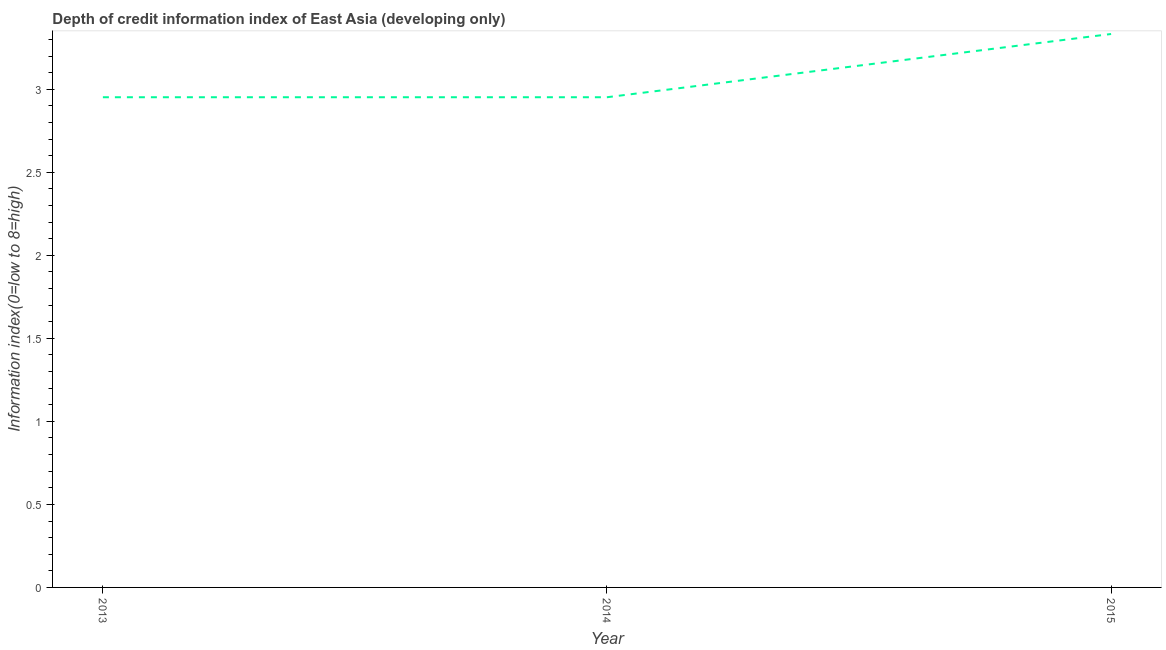What is the depth of credit information index in 2015?
Your answer should be very brief. 3.33. Across all years, what is the maximum depth of credit information index?
Keep it short and to the point. 3.33. Across all years, what is the minimum depth of credit information index?
Provide a short and direct response. 2.95. In which year was the depth of credit information index maximum?
Your answer should be very brief. 2015. In which year was the depth of credit information index minimum?
Provide a succinct answer. 2013. What is the sum of the depth of credit information index?
Offer a terse response. 9.24. What is the difference between the depth of credit information index in 2013 and 2015?
Your answer should be very brief. -0.38. What is the average depth of credit information index per year?
Your answer should be very brief. 3.08. What is the median depth of credit information index?
Your answer should be compact. 2.95. Do a majority of the years between 2015 and 2014 (inclusive) have depth of credit information index greater than 3.2 ?
Provide a succinct answer. No. Is the depth of credit information index in 2013 less than that in 2015?
Your response must be concise. Yes. Is the difference between the depth of credit information index in 2014 and 2015 greater than the difference between any two years?
Provide a short and direct response. Yes. What is the difference between the highest and the second highest depth of credit information index?
Provide a short and direct response. 0.38. What is the difference between the highest and the lowest depth of credit information index?
Offer a terse response. 0.38. Does the depth of credit information index monotonically increase over the years?
Keep it short and to the point. No. How many lines are there?
Provide a short and direct response. 1. How many years are there in the graph?
Offer a very short reply. 3. Does the graph contain any zero values?
Provide a succinct answer. No. What is the title of the graph?
Offer a very short reply. Depth of credit information index of East Asia (developing only). What is the label or title of the Y-axis?
Offer a terse response. Information index(0=low to 8=high). What is the Information index(0=low to 8=high) in 2013?
Ensure brevity in your answer.  2.95. What is the Information index(0=low to 8=high) in 2014?
Provide a short and direct response. 2.95. What is the Information index(0=low to 8=high) in 2015?
Your response must be concise. 3.33. What is the difference between the Information index(0=low to 8=high) in 2013 and 2015?
Offer a terse response. -0.38. What is the difference between the Information index(0=low to 8=high) in 2014 and 2015?
Keep it short and to the point. -0.38. What is the ratio of the Information index(0=low to 8=high) in 2013 to that in 2015?
Provide a short and direct response. 0.89. What is the ratio of the Information index(0=low to 8=high) in 2014 to that in 2015?
Your response must be concise. 0.89. 